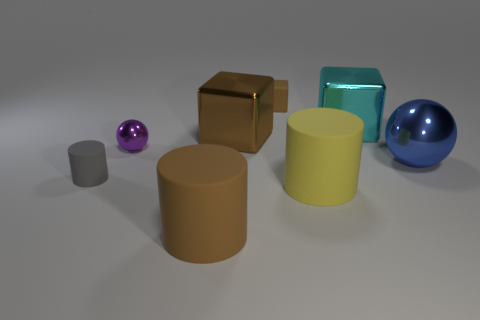Add 2 tiny blue rubber cylinders. How many objects exist? 10 Subtract all blocks. How many objects are left? 5 Add 5 blocks. How many blocks exist? 8 Subtract 0 cyan cylinders. How many objects are left? 8 Subtract all gray rubber cylinders. Subtract all tiny purple objects. How many objects are left? 6 Add 1 big brown cylinders. How many big brown cylinders are left? 2 